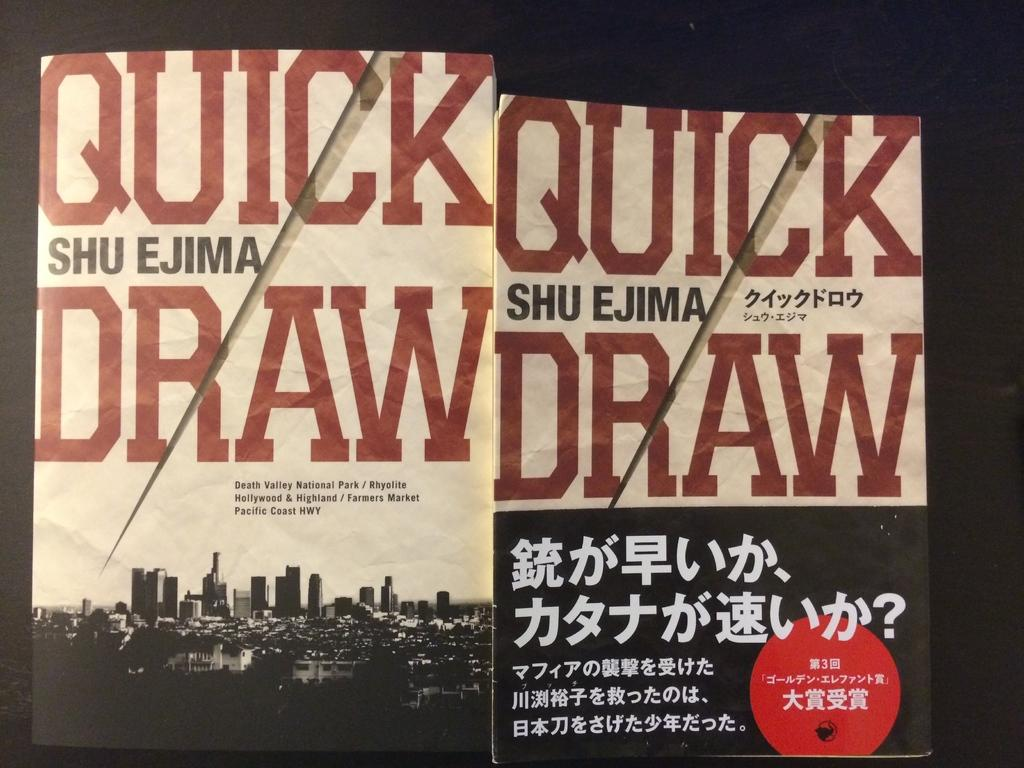<image>
Render a clear and concise summary of the photo. Two posters for Quick Draw showing a city scape on the left and asian writing on the other poster. 